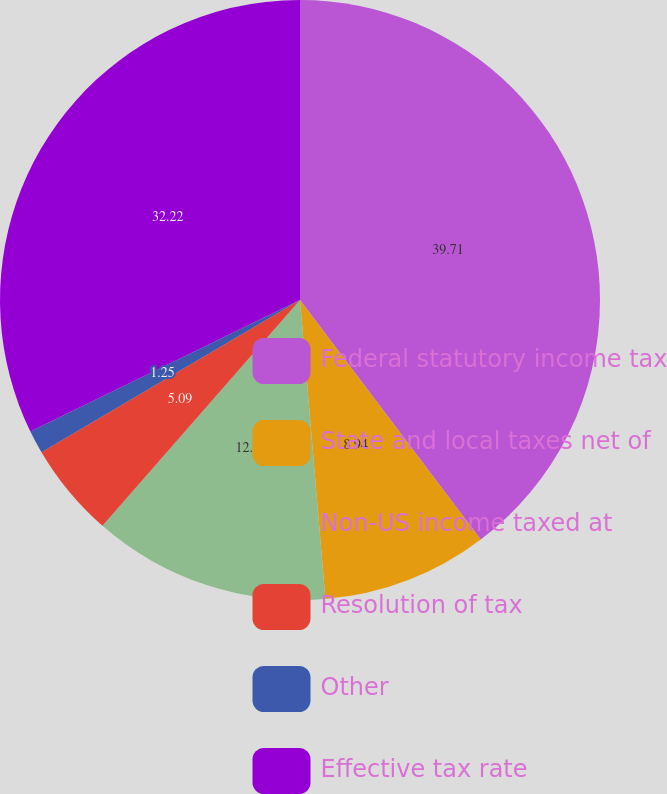Convert chart. <chart><loc_0><loc_0><loc_500><loc_500><pie_chart><fcel>Federal statutory income tax<fcel>State and local taxes net of<fcel>Non-US income taxed at<fcel>Resolution of tax<fcel>Other<fcel>Effective tax rate<nl><fcel>39.71%<fcel>8.94%<fcel>12.79%<fcel>5.09%<fcel>1.25%<fcel>32.22%<nl></chart> 